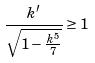<formula> <loc_0><loc_0><loc_500><loc_500>\frac { k ^ { \prime } } { \sqrt { 1 - \frac { k ^ { 5 } } { 7 } } } \geq 1</formula> 